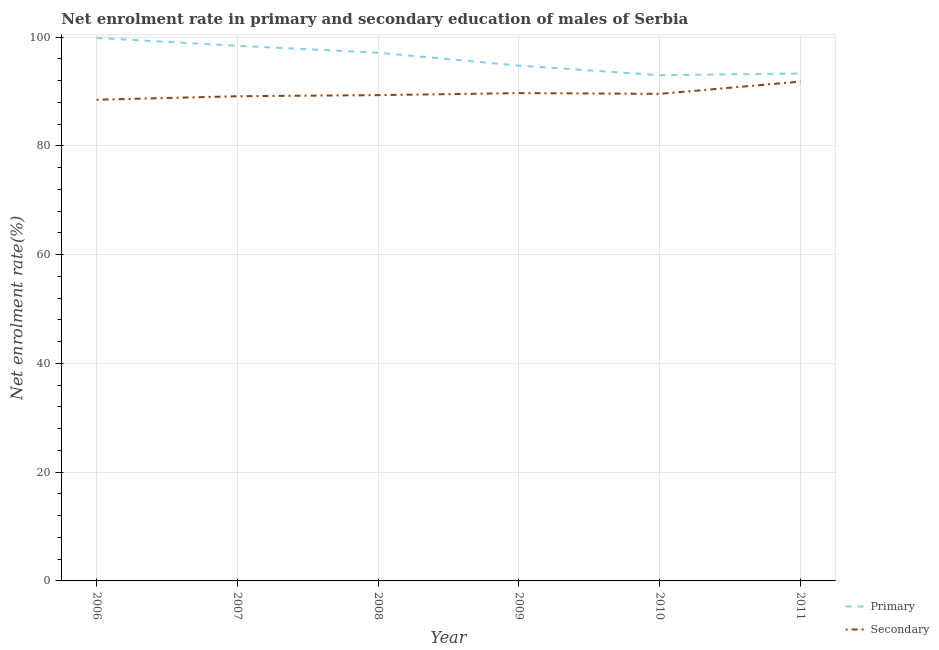Is the number of lines equal to the number of legend labels?
Keep it short and to the point. Yes. What is the enrollment rate in secondary education in 2011?
Offer a very short reply. 91.82. Across all years, what is the maximum enrollment rate in primary education?
Provide a succinct answer. 99.84. Across all years, what is the minimum enrollment rate in secondary education?
Give a very brief answer. 88.48. What is the total enrollment rate in secondary education in the graph?
Ensure brevity in your answer.  537.99. What is the difference between the enrollment rate in primary education in 2006 and that in 2008?
Offer a very short reply. 2.71. What is the difference between the enrollment rate in primary education in 2009 and the enrollment rate in secondary education in 2008?
Give a very brief answer. 5.43. What is the average enrollment rate in secondary education per year?
Your answer should be very brief. 89.67. In the year 2007, what is the difference between the enrollment rate in primary education and enrollment rate in secondary education?
Offer a terse response. 9.27. What is the ratio of the enrollment rate in primary education in 2006 to that in 2007?
Keep it short and to the point. 1.01. Is the enrollment rate in secondary education in 2009 less than that in 2011?
Your answer should be very brief. Yes. Is the difference between the enrollment rate in secondary education in 2006 and 2007 greater than the difference between the enrollment rate in primary education in 2006 and 2007?
Offer a terse response. No. What is the difference between the highest and the second highest enrollment rate in secondary education?
Give a very brief answer. 2.12. What is the difference between the highest and the lowest enrollment rate in primary education?
Your answer should be compact. 6.84. In how many years, is the enrollment rate in secondary education greater than the average enrollment rate in secondary education taken over all years?
Make the answer very short. 2. Is the sum of the enrollment rate in primary education in 2006 and 2009 greater than the maximum enrollment rate in secondary education across all years?
Ensure brevity in your answer.  Yes. Is the enrollment rate in secondary education strictly greater than the enrollment rate in primary education over the years?
Offer a terse response. No. Is the enrollment rate in secondary education strictly less than the enrollment rate in primary education over the years?
Give a very brief answer. Yes. How many years are there in the graph?
Your answer should be compact. 6. What is the difference between two consecutive major ticks on the Y-axis?
Offer a very short reply. 20. Are the values on the major ticks of Y-axis written in scientific E-notation?
Make the answer very short. No. Where does the legend appear in the graph?
Offer a very short reply. Bottom right. How are the legend labels stacked?
Your response must be concise. Vertical. What is the title of the graph?
Give a very brief answer. Net enrolment rate in primary and secondary education of males of Serbia. What is the label or title of the X-axis?
Offer a very short reply. Year. What is the label or title of the Y-axis?
Offer a terse response. Net enrolment rate(%). What is the Net enrolment rate(%) of Primary in 2006?
Your response must be concise. 99.84. What is the Net enrolment rate(%) in Secondary in 2006?
Offer a very short reply. 88.48. What is the Net enrolment rate(%) of Primary in 2007?
Offer a terse response. 98.4. What is the Net enrolment rate(%) of Secondary in 2007?
Your response must be concise. 89.12. What is the Net enrolment rate(%) of Primary in 2008?
Provide a succinct answer. 97.13. What is the Net enrolment rate(%) in Secondary in 2008?
Offer a very short reply. 89.32. What is the Net enrolment rate(%) in Primary in 2009?
Your response must be concise. 94.75. What is the Net enrolment rate(%) of Secondary in 2009?
Your answer should be very brief. 89.7. What is the Net enrolment rate(%) in Primary in 2010?
Ensure brevity in your answer.  92.99. What is the Net enrolment rate(%) in Secondary in 2010?
Provide a succinct answer. 89.56. What is the Net enrolment rate(%) of Primary in 2011?
Offer a very short reply. 93.3. What is the Net enrolment rate(%) in Secondary in 2011?
Provide a succinct answer. 91.82. Across all years, what is the maximum Net enrolment rate(%) of Primary?
Make the answer very short. 99.84. Across all years, what is the maximum Net enrolment rate(%) of Secondary?
Your answer should be very brief. 91.82. Across all years, what is the minimum Net enrolment rate(%) of Primary?
Your answer should be very brief. 92.99. Across all years, what is the minimum Net enrolment rate(%) in Secondary?
Provide a succinct answer. 88.48. What is the total Net enrolment rate(%) of Primary in the graph?
Your response must be concise. 576.41. What is the total Net enrolment rate(%) in Secondary in the graph?
Your answer should be compact. 537.99. What is the difference between the Net enrolment rate(%) in Primary in 2006 and that in 2007?
Provide a short and direct response. 1.44. What is the difference between the Net enrolment rate(%) in Secondary in 2006 and that in 2007?
Offer a very short reply. -0.65. What is the difference between the Net enrolment rate(%) in Primary in 2006 and that in 2008?
Keep it short and to the point. 2.71. What is the difference between the Net enrolment rate(%) in Secondary in 2006 and that in 2008?
Provide a short and direct response. -0.85. What is the difference between the Net enrolment rate(%) in Primary in 2006 and that in 2009?
Your response must be concise. 5.08. What is the difference between the Net enrolment rate(%) of Secondary in 2006 and that in 2009?
Your answer should be very brief. -1.22. What is the difference between the Net enrolment rate(%) of Primary in 2006 and that in 2010?
Your answer should be very brief. 6.84. What is the difference between the Net enrolment rate(%) in Secondary in 2006 and that in 2010?
Your response must be concise. -1.08. What is the difference between the Net enrolment rate(%) of Primary in 2006 and that in 2011?
Give a very brief answer. 6.53. What is the difference between the Net enrolment rate(%) in Secondary in 2006 and that in 2011?
Your response must be concise. -3.34. What is the difference between the Net enrolment rate(%) in Primary in 2007 and that in 2008?
Offer a terse response. 1.27. What is the difference between the Net enrolment rate(%) in Secondary in 2007 and that in 2008?
Make the answer very short. -0.2. What is the difference between the Net enrolment rate(%) in Primary in 2007 and that in 2009?
Provide a succinct answer. 3.64. What is the difference between the Net enrolment rate(%) of Secondary in 2007 and that in 2009?
Your answer should be very brief. -0.57. What is the difference between the Net enrolment rate(%) in Primary in 2007 and that in 2010?
Your response must be concise. 5.41. What is the difference between the Net enrolment rate(%) of Secondary in 2007 and that in 2010?
Your answer should be very brief. -0.43. What is the difference between the Net enrolment rate(%) in Primary in 2007 and that in 2011?
Give a very brief answer. 5.09. What is the difference between the Net enrolment rate(%) in Secondary in 2007 and that in 2011?
Provide a short and direct response. -2.69. What is the difference between the Net enrolment rate(%) of Primary in 2008 and that in 2009?
Keep it short and to the point. 2.37. What is the difference between the Net enrolment rate(%) in Secondary in 2008 and that in 2009?
Ensure brevity in your answer.  -0.37. What is the difference between the Net enrolment rate(%) in Primary in 2008 and that in 2010?
Your response must be concise. 4.13. What is the difference between the Net enrolment rate(%) in Secondary in 2008 and that in 2010?
Offer a very short reply. -0.23. What is the difference between the Net enrolment rate(%) of Primary in 2008 and that in 2011?
Make the answer very short. 3.82. What is the difference between the Net enrolment rate(%) in Secondary in 2008 and that in 2011?
Give a very brief answer. -2.49. What is the difference between the Net enrolment rate(%) of Primary in 2009 and that in 2010?
Ensure brevity in your answer.  1.76. What is the difference between the Net enrolment rate(%) in Secondary in 2009 and that in 2010?
Make the answer very short. 0.14. What is the difference between the Net enrolment rate(%) in Primary in 2009 and that in 2011?
Provide a short and direct response. 1.45. What is the difference between the Net enrolment rate(%) in Secondary in 2009 and that in 2011?
Your response must be concise. -2.12. What is the difference between the Net enrolment rate(%) of Primary in 2010 and that in 2011?
Offer a terse response. -0.31. What is the difference between the Net enrolment rate(%) of Secondary in 2010 and that in 2011?
Ensure brevity in your answer.  -2.26. What is the difference between the Net enrolment rate(%) in Primary in 2006 and the Net enrolment rate(%) in Secondary in 2007?
Provide a short and direct response. 10.71. What is the difference between the Net enrolment rate(%) in Primary in 2006 and the Net enrolment rate(%) in Secondary in 2008?
Ensure brevity in your answer.  10.51. What is the difference between the Net enrolment rate(%) of Primary in 2006 and the Net enrolment rate(%) of Secondary in 2009?
Make the answer very short. 10.14. What is the difference between the Net enrolment rate(%) in Primary in 2006 and the Net enrolment rate(%) in Secondary in 2010?
Give a very brief answer. 10.28. What is the difference between the Net enrolment rate(%) of Primary in 2006 and the Net enrolment rate(%) of Secondary in 2011?
Give a very brief answer. 8.02. What is the difference between the Net enrolment rate(%) in Primary in 2007 and the Net enrolment rate(%) in Secondary in 2008?
Ensure brevity in your answer.  9.07. What is the difference between the Net enrolment rate(%) in Primary in 2007 and the Net enrolment rate(%) in Secondary in 2009?
Make the answer very short. 8.7. What is the difference between the Net enrolment rate(%) in Primary in 2007 and the Net enrolment rate(%) in Secondary in 2010?
Give a very brief answer. 8.84. What is the difference between the Net enrolment rate(%) of Primary in 2007 and the Net enrolment rate(%) of Secondary in 2011?
Your answer should be compact. 6.58. What is the difference between the Net enrolment rate(%) in Primary in 2008 and the Net enrolment rate(%) in Secondary in 2009?
Offer a very short reply. 7.43. What is the difference between the Net enrolment rate(%) of Primary in 2008 and the Net enrolment rate(%) of Secondary in 2010?
Your response must be concise. 7.57. What is the difference between the Net enrolment rate(%) of Primary in 2008 and the Net enrolment rate(%) of Secondary in 2011?
Give a very brief answer. 5.31. What is the difference between the Net enrolment rate(%) in Primary in 2009 and the Net enrolment rate(%) in Secondary in 2010?
Your answer should be compact. 5.2. What is the difference between the Net enrolment rate(%) of Primary in 2009 and the Net enrolment rate(%) of Secondary in 2011?
Provide a succinct answer. 2.94. What is the difference between the Net enrolment rate(%) of Primary in 2010 and the Net enrolment rate(%) of Secondary in 2011?
Your answer should be compact. 1.18. What is the average Net enrolment rate(%) of Primary per year?
Offer a terse response. 96.07. What is the average Net enrolment rate(%) in Secondary per year?
Offer a terse response. 89.67. In the year 2006, what is the difference between the Net enrolment rate(%) of Primary and Net enrolment rate(%) of Secondary?
Provide a short and direct response. 11.36. In the year 2007, what is the difference between the Net enrolment rate(%) in Primary and Net enrolment rate(%) in Secondary?
Provide a short and direct response. 9.27. In the year 2008, what is the difference between the Net enrolment rate(%) in Primary and Net enrolment rate(%) in Secondary?
Your answer should be very brief. 7.8. In the year 2009, what is the difference between the Net enrolment rate(%) in Primary and Net enrolment rate(%) in Secondary?
Offer a very short reply. 5.06. In the year 2010, what is the difference between the Net enrolment rate(%) in Primary and Net enrolment rate(%) in Secondary?
Your answer should be compact. 3.43. In the year 2011, what is the difference between the Net enrolment rate(%) of Primary and Net enrolment rate(%) of Secondary?
Provide a succinct answer. 1.49. What is the ratio of the Net enrolment rate(%) in Primary in 2006 to that in 2007?
Ensure brevity in your answer.  1.01. What is the ratio of the Net enrolment rate(%) of Secondary in 2006 to that in 2007?
Provide a succinct answer. 0.99. What is the ratio of the Net enrolment rate(%) of Primary in 2006 to that in 2008?
Your response must be concise. 1.03. What is the ratio of the Net enrolment rate(%) in Secondary in 2006 to that in 2008?
Provide a short and direct response. 0.99. What is the ratio of the Net enrolment rate(%) in Primary in 2006 to that in 2009?
Give a very brief answer. 1.05. What is the ratio of the Net enrolment rate(%) in Secondary in 2006 to that in 2009?
Keep it short and to the point. 0.99. What is the ratio of the Net enrolment rate(%) in Primary in 2006 to that in 2010?
Your response must be concise. 1.07. What is the ratio of the Net enrolment rate(%) in Secondary in 2006 to that in 2010?
Ensure brevity in your answer.  0.99. What is the ratio of the Net enrolment rate(%) in Primary in 2006 to that in 2011?
Your answer should be very brief. 1.07. What is the ratio of the Net enrolment rate(%) in Secondary in 2006 to that in 2011?
Your answer should be compact. 0.96. What is the ratio of the Net enrolment rate(%) of Primary in 2007 to that in 2008?
Keep it short and to the point. 1.01. What is the ratio of the Net enrolment rate(%) of Primary in 2007 to that in 2009?
Provide a succinct answer. 1.04. What is the ratio of the Net enrolment rate(%) of Primary in 2007 to that in 2010?
Give a very brief answer. 1.06. What is the ratio of the Net enrolment rate(%) in Secondary in 2007 to that in 2010?
Make the answer very short. 1. What is the ratio of the Net enrolment rate(%) in Primary in 2007 to that in 2011?
Make the answer very short. 1.05. What is the ratio of the Net enrolment rate(%) of Secondary in 2007 to that in 2011?
Keep it short and to the point. 0.97. What is the ratio of the Net enrolment rate(%) in Primary in 2008 to that in 2010?
Provide a short and direct response. 1.04. What is the ratio of the Net enrolment rate(%) of Secondary in 2008 to that in 2010?
Your answer should be compact. 1. What is the ratio of the Net enrolment rate(%) in Primary in 2008 to that in 2011?
Keep it short and to the point. 1.04. What is the ratio of the Net enrolment rate(%) of Secondary in 2008 to that in 2011?
Your answer should be very brief. 0.97. What is the ratio of the Net enrolment rate(%) of Primary in 2009 to that in 2010?
Provide a short and direct response. 1.02. What is the ratio of the Net enrolment rate(%) in Secondary in 2009 to that in 2010?
Your answer should be compact. 1. What is the ratio of the Net enrolment rate(%) of Primary in 2009 to that in 2011?
Give a very brief answer. 1.02. What is the ratio of the Net enrolment rate(%) in Secondary in 2009 to that in 2011?
Provide a succinct answer. 0.98. What is the ratio of the Net enrolment rate(%) in Primary in 2010 to that in 2011?
Offer a terse response. 1. What is the ratio of the Net enrolment rate(%) in Secondary in 2010 to that in 2011?
Provide a short and direct response. 0.98. What is the difference between the highest and the second highest Net enrolment rate(%) in Primary?
Provide a short and direct response. 1.44. What is the difference between the highest and the second highest Net enrolment rate(%) of Secondary?
Make the answer very short. 2.12. What is the difference between the highest and the lowest Net enrolment rate(%) in Primary?
Your answer should be compact. 6.84. What is the difference between the highest and the lowest Net enrolment rate(%) of Secondary?
Ensure brevity in your answer.  3.34. 